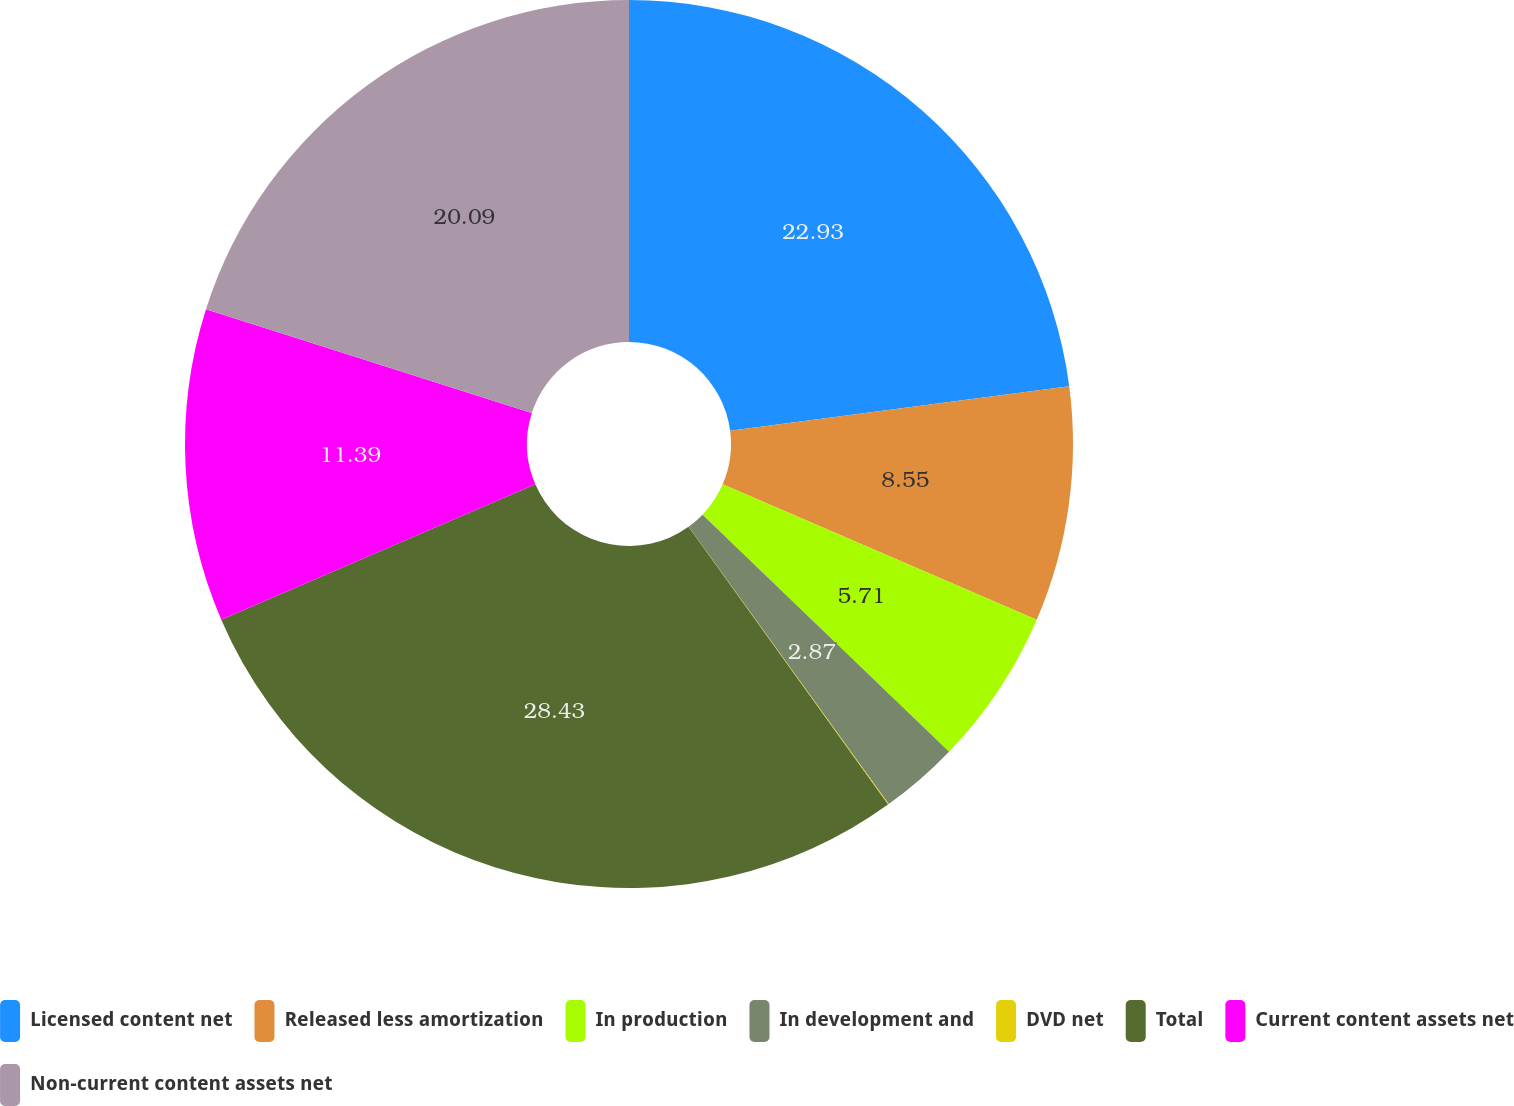Convert chart. <chart><loc_0><loc_0><loc_500><loc_500><pie_chart><fcel>Licensed content net<fcel>Released less amortization<fcel>In production<fcel>In development and<fcel>DVD net<fcel>Total<fcel>Current content assets net<fcel>Non-current content assets net<nl><fcel>22.93%<fcel>8.55%<fcel>5.71%<fcel>2.87%<fcel>0.03%<fcel>28.44%<fcel>11.39%<fcel>20.09%<nl></chart> 